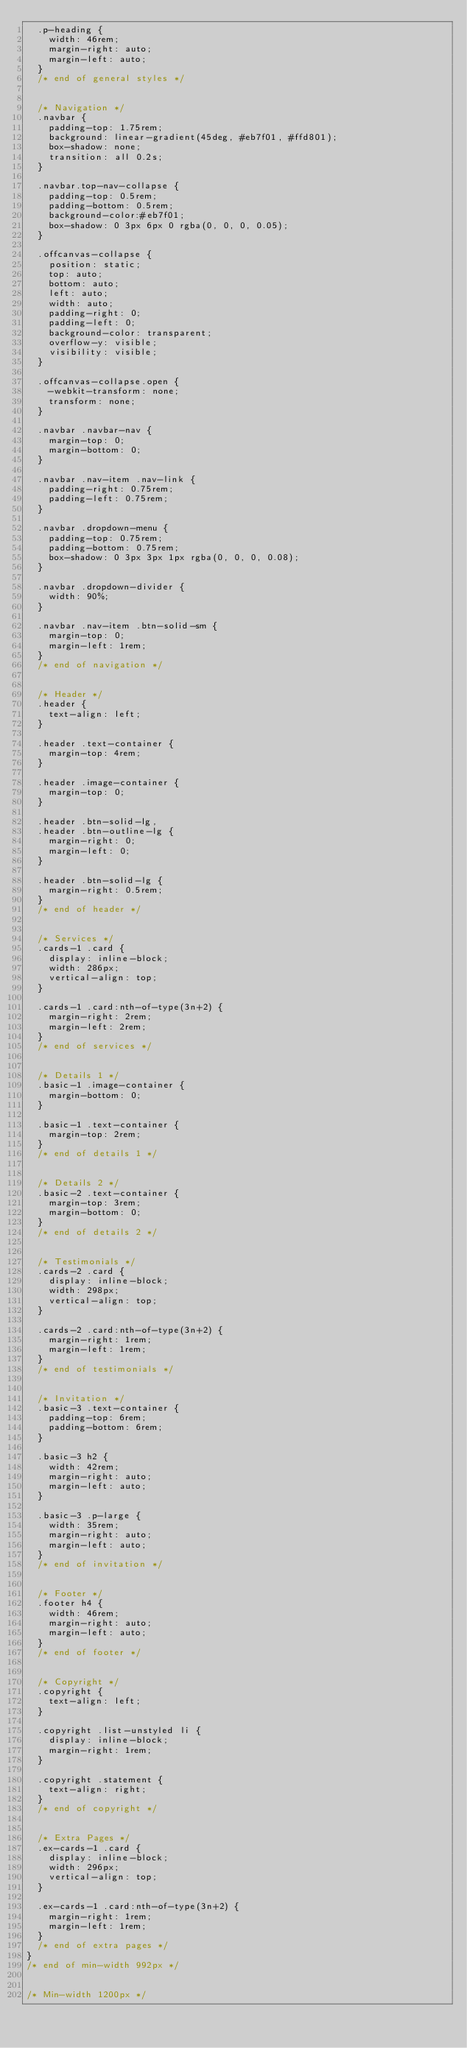Convert code to text. <code><loc_0><loc_0><loc_500><loc_500><_CSS_>	.p-heading {
		width: 46rem;
		margin-right: auto;
		margin-left: auto;
	}
	/* end of general styles */


	/* Navigation */
	.navbar {
		padding-top: 1.75rem;
		background: linear-gradient(45deg, #eb7f01, #ffd801);
		box-shadow: none;
		transition: all 0.2s;
	}

	.navbar.top-nav-collapse {
		padding-top: 0.5rem;
		padding-bottom: 0.5rem;
		background-color:#eb7f01;
		box-shadow: 0 3px 6px 0 rgba(0, 0, 0, 0.05);
	}

	.offcanvas-collapse {
		position: static;
		top: auto;
		bottom: auto;
		left: auto;
		width: auto;
		padding-right: 0;
		padding-left: 0;
		background-color: transparent;
		overflow-y: visible;
		visibility: visible;
	}

	.offcanvas-collapse.open {
		-webkit-transform: none;
		transform: none;
	}

	.navbar .navbar-nav {
		margin-top: 0;
		margin-bottom: 0;
	}
	
	.navbar .nav-item .nav-link {
		padding-right: 0.75rem;
		padding-left: 0.75rem;
	}

	.navbar .dropdown-menu {
		padding-top: 0.75rem;
		padding-bottom: 0.75rem;
		box-shadow: 0 3px 3px 1px rgba(0, 0, 0, 0.08);
	}

	.navbar .dropdown-divider {
		width: 90%;
	}

	.navbar .nav-item .btn-solid-sm {
		margin-top: 0;
		margin-left: 1rem;
	}
	/* end of navigation */


	/* Header */
	.header {
		text-align: left;
	}

	.header .text-container {
		margin-top: 4rem;
	}

	.header .image-container {
		margin-top: 0;
	}

	.header .btn-solid-lg,
	.header .btn-outline-lg {
		margin-right: 0;
		margin-left: 0;
	}
	
	.header .btn-solid-lg {
		margin-right: 0.5rem;
	}
	/* end of header */


	/* Services */
	.cards-1 .card {
		display: inline-block;
		width: 286px;
		vertical-align: top;
	}
	
	.cards-1 .card:nth-of-type(3n+2) {
		margin-right: 2rem;
		margin-left: 2rem;
	}
	/* end of services */


	/* Details 1 */
	.basic-1 .image-container {
		margin-bottom: 0;
	}

	.basic-1 .text-container {
		margin-top: 2rem;
	}
	/* end of details 1 */
	
	
	/* Details 2 */
	.basic-2 .text-container {
		margin-top: 3rem;
		margin-bottom: 0;
	}
	/* end of details 2 */


	/* Testimonials */
	.cards-2 .card {
		display: inline-block;
		width: 298px;
		vertical-align: top;
	}
	
	.cards-2 .card:nth-of-type(3n+2) {
		margin-right: 1rem;
		margin-left: 1rem;
	}
	/* end of testimonials */


	/* Invitation */
	.basic-3 .text-container {
		padding-top: 6rem;
		padding-bottom: 6rem;
	}

	.basic-3 h2 {
		width: 42rem;
		margin-right: auto;
		margin-left: auto;
	}

	.basic-3 .p-large {
		width: 35rem;
		margin-right: auto;
		margin-left: auto;
	}
	/* end of invitation */


	/* Footer */
	.footer h4 {
		width: 46rem;
		margin-right: auto;
		margin-left: auto;
	}
	/* end of footer */


	/* Copyright */
	.copyright {
		text-align: left;
	}

	.copyright .list-unstyled li {
		display: inline-block;
		margin-right: 1rem;
	}

	.copyright .statement {
		text-align: right;
	}
	/* end of copyright */


	/* Extra Pages */
	.ex-cards-1 .card {
		display: inline-block;
		width: 296px;
		vertical-align: top;
	}

	.ex-cards-1 .card:nth-of-type(3n+2) {
		margin-right: 1rem;
		margin-left: 1rem;
	}
	/* end of extra pages */
}
/* end of min-width 992px */


/* Min-width 1200px */</code> 